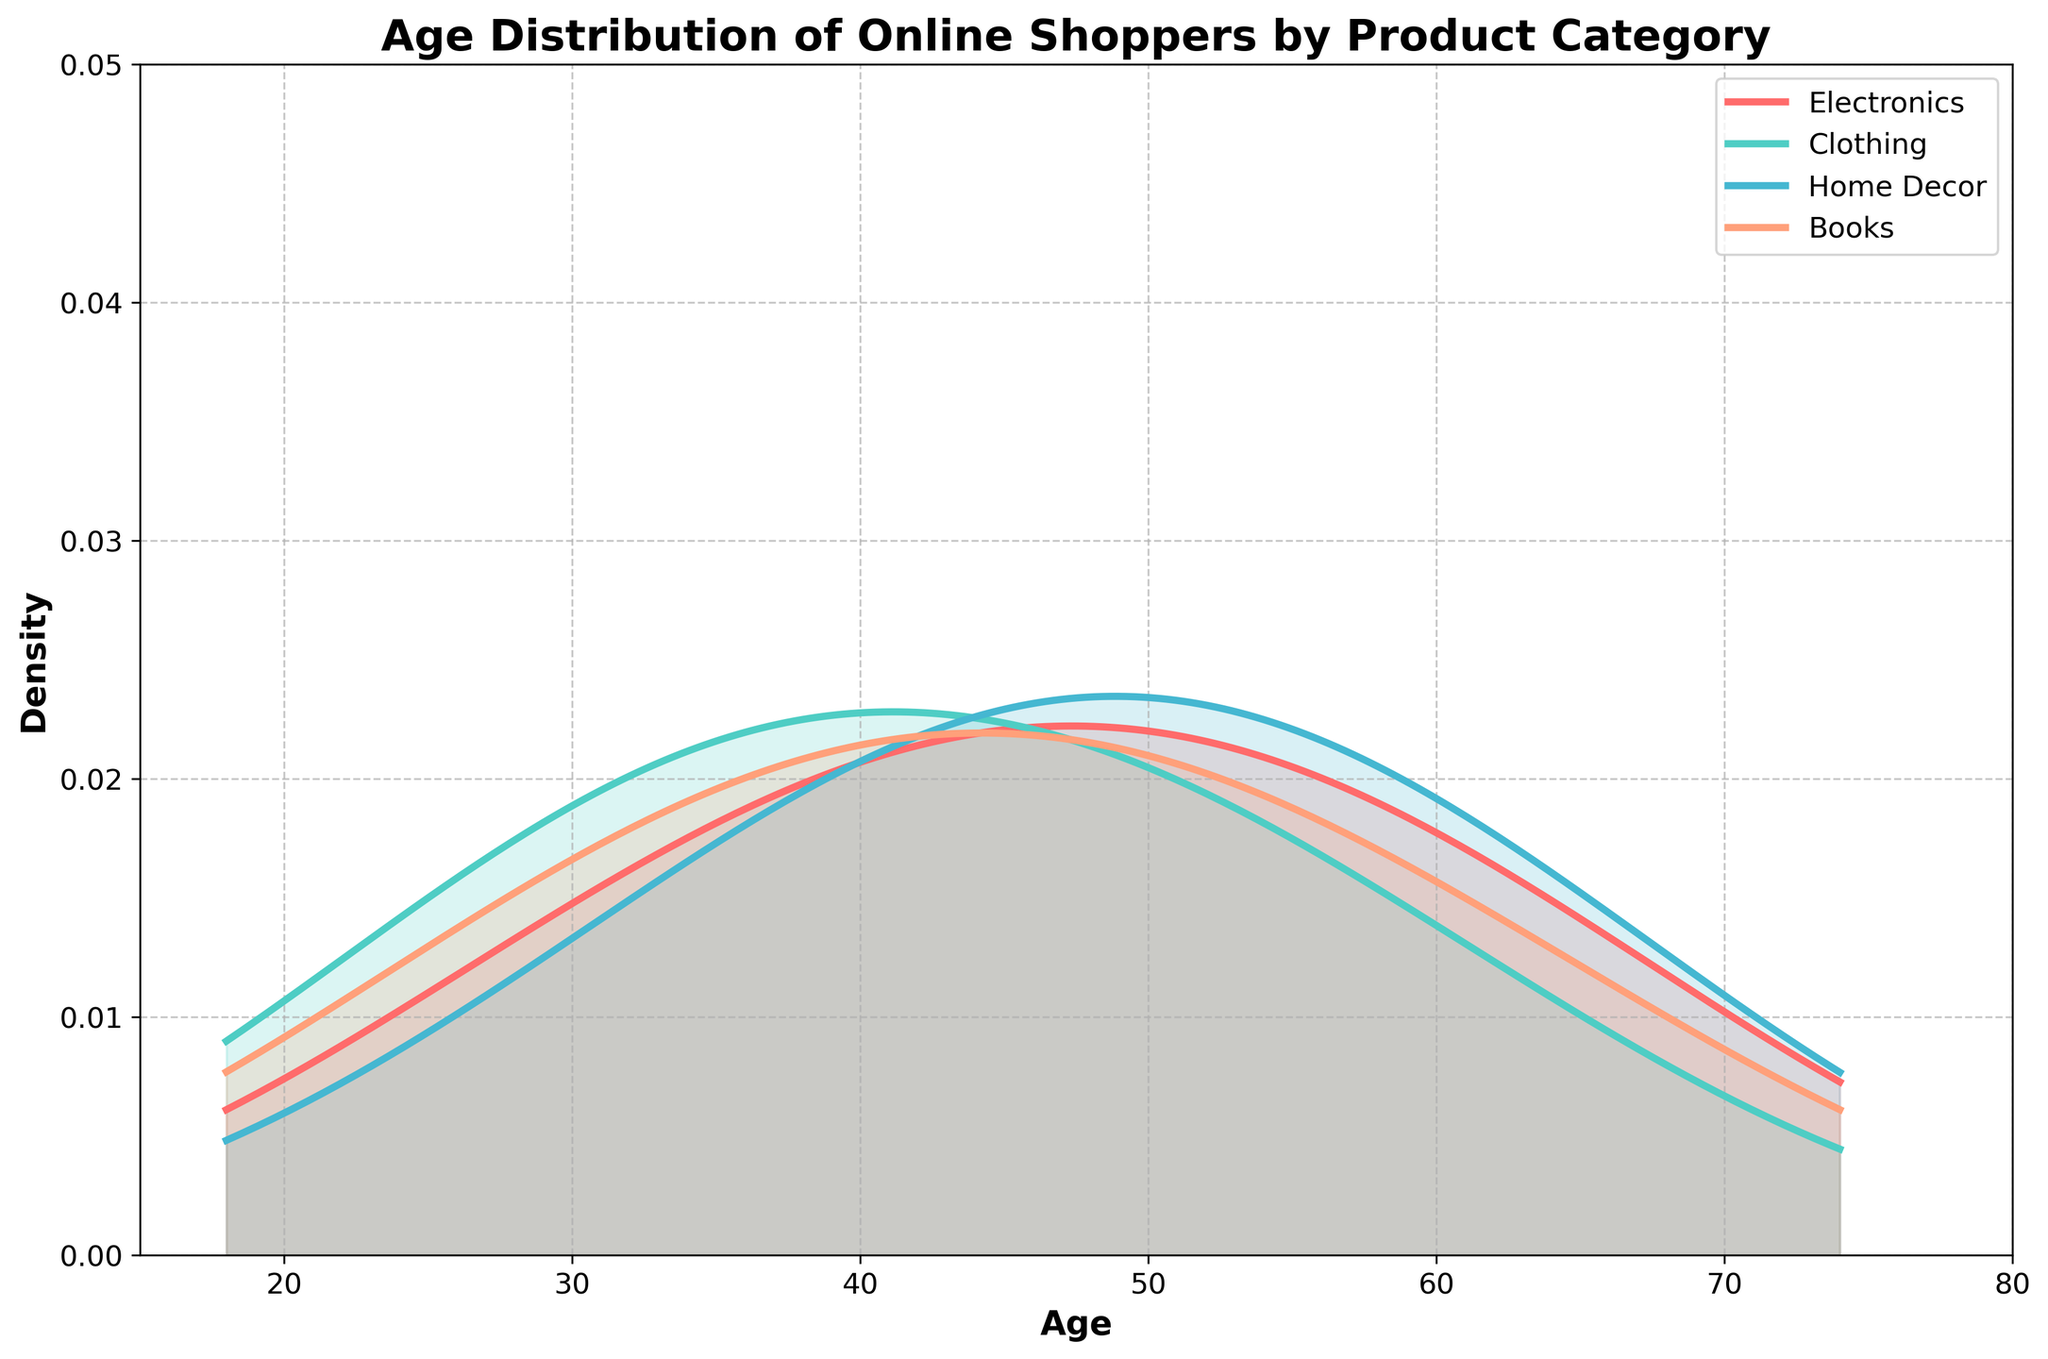Which product category has the highest peak density for the age group 46? The plot shows density curves for different product categories, and the height of the curves at each age represents density. The Home Decor category has the highest peak density at age 46, indicated by the tallest peak at that age.
Answer: Home Decor What is the title of the figure? The title is located at the top of the figure and provides a summary of what the plot represents. In this case, it's 'Age Distribution of Online Shoppers by Product Category'.
Answer: Age Distribution of Online Shoppers by Product Category Which product category captures the youngest age group with a notable density? The plot shows density curves starting from age 18. Among the categories, Clothing has a notable density at age 18 compared to others.
Answer: Clothing Considering the density peaks, which product category is preferred by older age groups, specifically around age 60? The density peaks for each category indicate preference. The highest density around age 60 is seen in the Home Decor category.
Answer: Home Decor Comparing Electronics and Books, which category has a higher density for the age group 39? At age 39, the density for each category can be compared by looking at the height of the curves. Books have a higher density at age 39 compared to Electronics.
Answer: Books Does any product category show significant density for age 74? The density curves' heights at age 74 represent significant densities. There is no significant density for any category at age 74; they all show very low densities.
Answer: No Which age group shows the highest density for the Clothing category? By examining the curve for the Clothing category, the highest peak density is observed around age 39.
Answer: 39 For the Electronics category, are there more shoppers closer to age 30 or age 50? The density curve shows that the density at age 50 is higher than that at age 30 for the Electronics category. Hence, there are more shoppers closer to age 50.
Answer: Age 50 Which product categories overlap considerably in their age distributions between age 25 and 35? By examining the density curves between age 25 and 35, Clothing and Books show considerable overlap in their age distributions.
Answer: Clothing and Books 